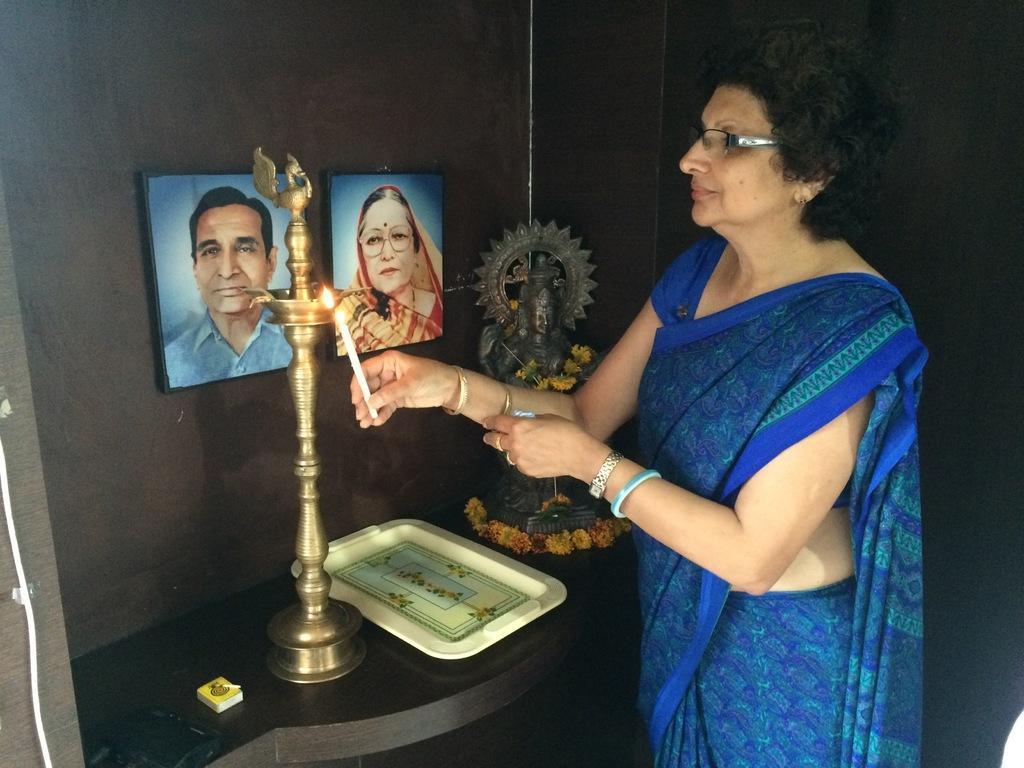Could you give a brief overview of what you see in this image? In this image we can see a woman holding the candle. We can also see an idol, flowers, plate and a matchbox on the counter. We can see the photo frames attached to the wall. We can also see an object on the counter. 